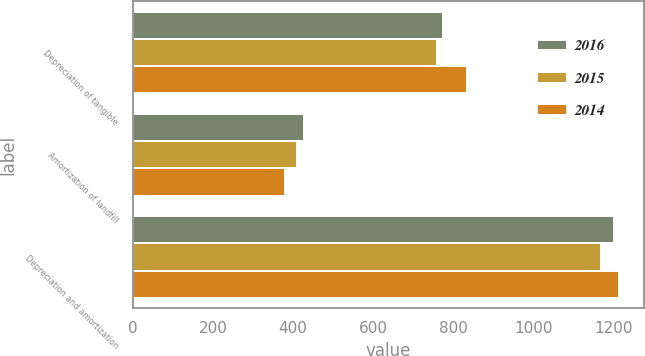<chart> <loc_0><loc_0><loc_500><loc_500><stacked_bar_chart><ecel><fcel>Depreciation of tangible<fcel>Amortization of landfill<fcel>Depreciation and amortization<nl><fcel>2016<fcel>773<fcel>428<fcel>1201<nl><fcel>2015<fcel>760<fcel>409<fcel>1169<nl><fcel>2014<fcel>834<fcel>380<fcel>1214<nl></chart> 